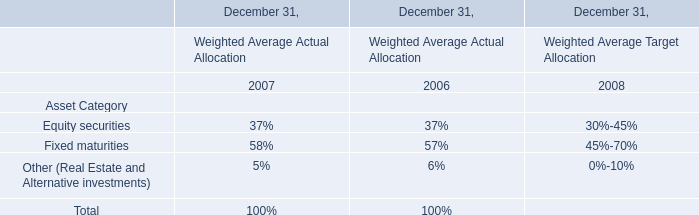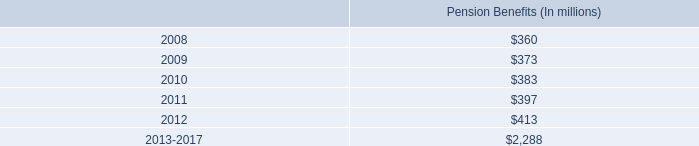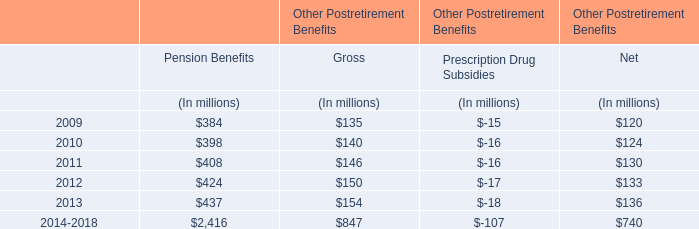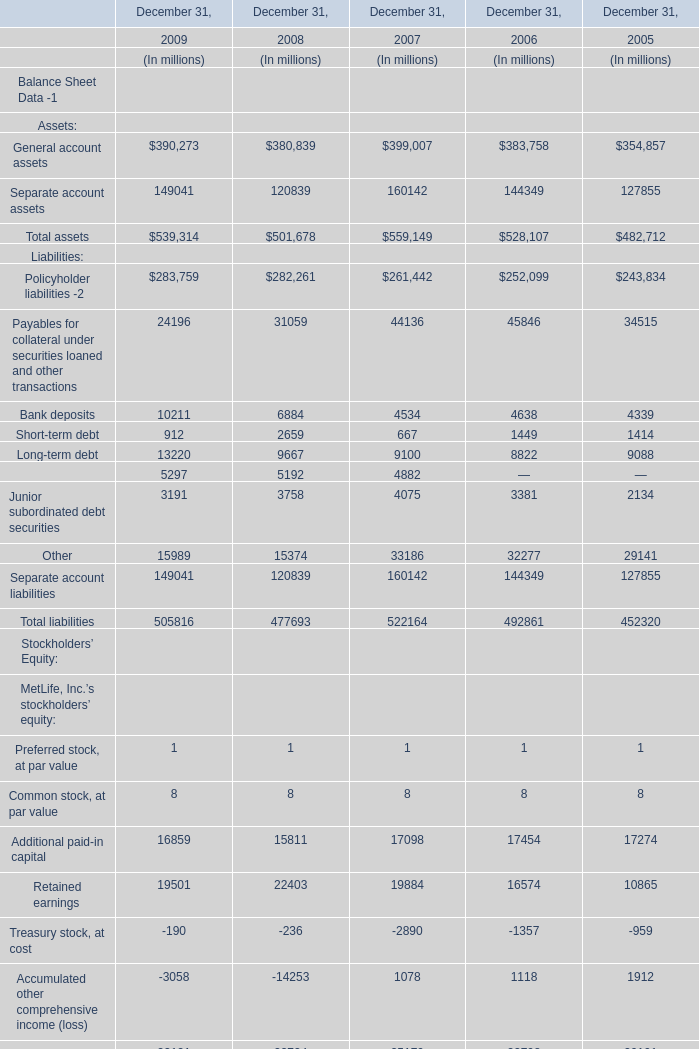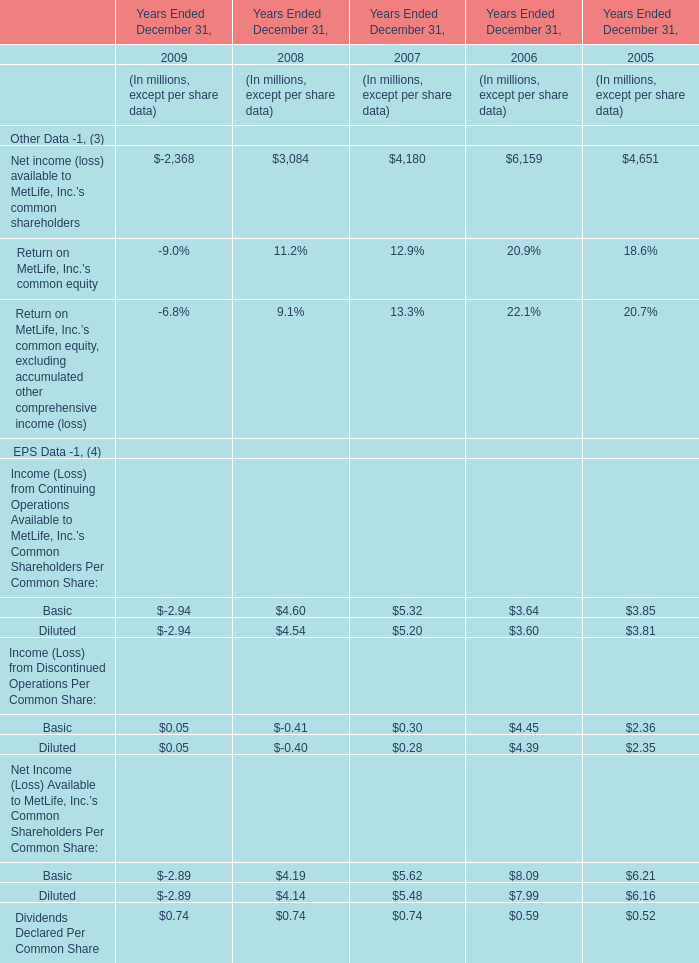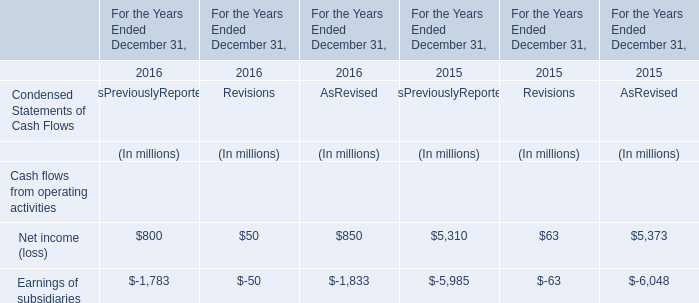Which year is Net income (loss) available to MetLife, Inc.'s common shareholders the most? 
Answer: 2006. 